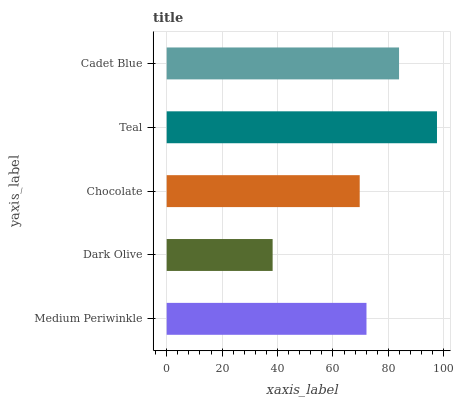Is Dark Olive the minimum?
Answer yes or no. Yes. Is Teal the maximum?
Answer yes or no. Yes. Is Chocolate the minimum?
Answer yes or no. No. Is Chocolate the maximum?
Answer yes or no. No. Is Chocolate greater than Dark Olive?
Answer yes or no. Yes. Is Dark Olive less than Chocolate?
Answer yes or no. Yes. Is Dark Olive greater than Chocolate?
Answer yes or no. No. Is Chocolate less than Dark Olive?
Answer yes or no. No. Is Medium Periwinkle the high median?
Answer yes or no. Yes. Is Medium Periwinkle the low median?
Answer yes or no. Yes. Is Dark Olive the high median?
Answer yes or no. No. Is Cadet Blue the low median?
Answer yes or no. No. 